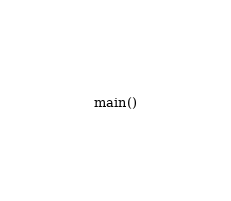Convert code to text. <code><loc_0><loc_0><loc_500><loc_500><_Python_>main()
</code> 